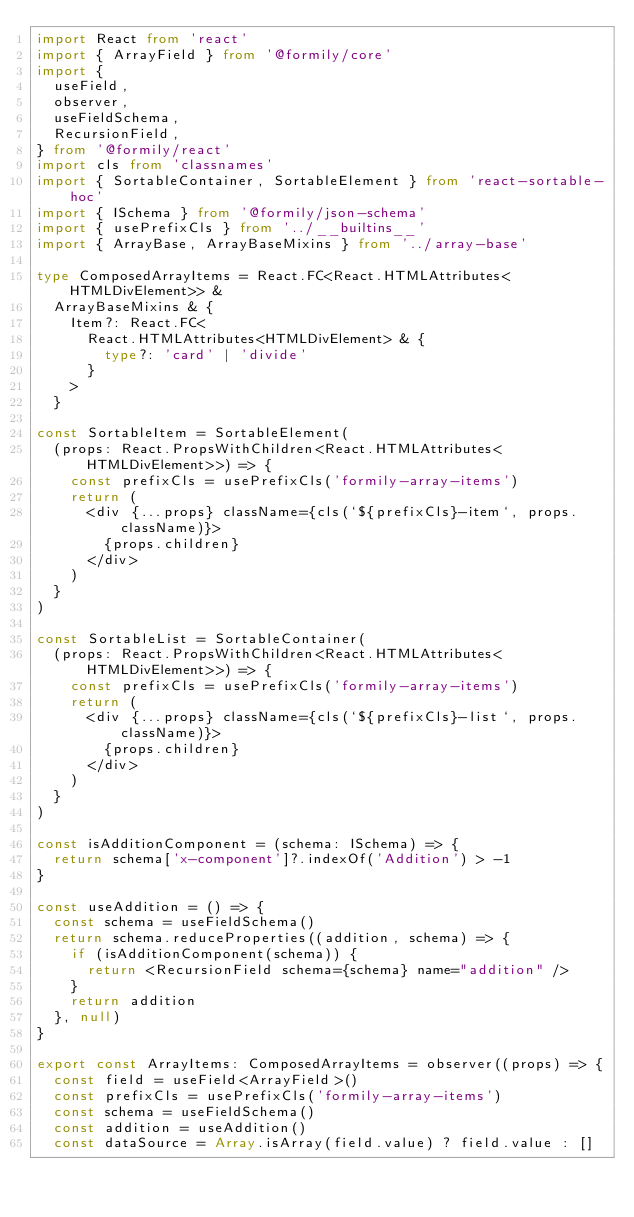<code> <loc_0><loc_0><loc_500><loc_500><_TypeScript_>import React from 'react'
import { ArrayField } from '@formily/core'
import {
  useField,
  observer,
  useFieldSchema,
  RecursionField,
} from '@formily/react'
import cls from 'classnames'
import { SortableContainer, SortableElement } from 'react-sortable-hoc'
import { ISchema } from '@formily/json-schema'
import { usePrefixCls } from '../__builtins__'
import { ArrayBase, ArrayBaseMixins } from '../array-base'

type ComposedArrayItems = React.FC<React.HTMLAttributes<HTMLDivElement>> &
  ArrayBaseMixins & {
    Item?: React.FC<
      React.HTMLAttributes<HTMLDivElement> & {
        type?: 'card' | 'divide'
      }
    >
  }

const SortableItem = SortableElement(
  (props: React.PropsWithChildren<React.HTMLAttributes<HTMLDivElement>>) => {
    const prefixCls = usePrefixCls('formily-array-items')
    return (
      <div {...props} className={cls(`${prefixCls}-item`, props.className)}>
        {props.children}
      </div>
    )
  }
)

const SortableList = SortableContainer(
  (props: React.PropsWithChildren<React.HTMLAttributes<HTMLDivElement>>) => {
    const prefixCls = usePrefixCls('formily-array-items')
    return (
      <div {...props} className={cls(`${prefixCls}-list`, props.className)}>
        {props.children}
      </div>
    )
  }
)

const isAdditionComponent = (schema: ISchema) => {
  return schema['x-component']?.indexOf('Addition') > -1
}

const useAddition = () => {
  const schema = useFieldSchema()
  return schema.reduceProperties((addition, schema) => {
    if (isAdditionComponent(schema)) {
      return <RecursionField schema={schema} name="addition" />
    }
    return addition
  }, null)
}

export const ArrayItems: ComposedArrayItems = observer((props) => {
  const field = useField<ArrayField>()
  const prefixCls = usePrefixCls('formily-array-items')
  const schema = useFieldSchema()
  const addition = useAddition()
  const dataSource = Array.isArray(field.value) ? field.value : []</code> 